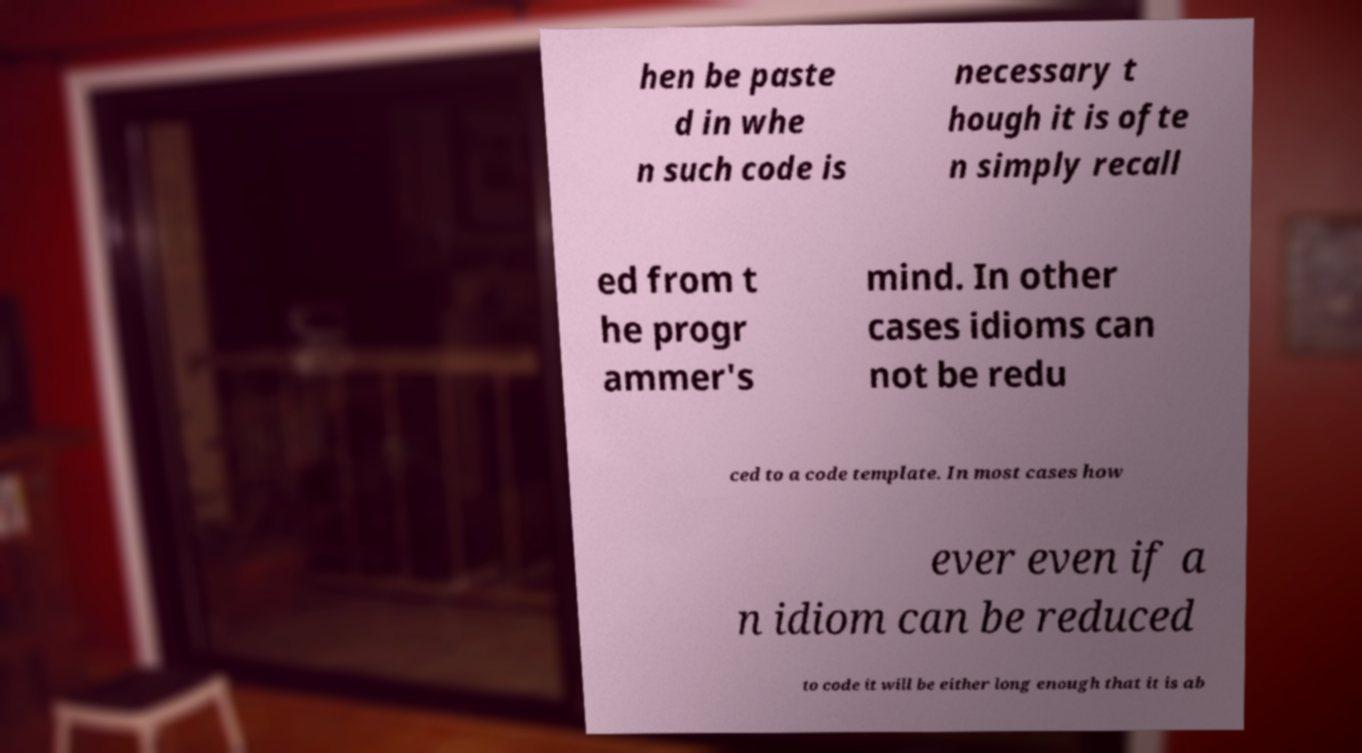For documentation purposes, I need the text within this image transcribed. Could you provide that? hen be paste d in whe n such code is necessary t hough it is ofte n simply recall ed from t he progr ammer's mind. In other cases idioms can not be redu ced to a code template. In most cases how ever even if a n idiom can be reduced to code it will be either long enough that it is ab 